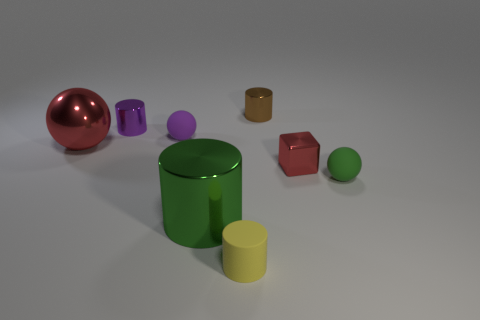What size is the purple object that is the same shape as the tiny green object?
Your answer should be compact. Small. There is a sphere that is behind the large red ball; does it have the same size as the sphere that is right of the tiny red cube?
Offer a terse response. Yes. What number of small objects are metallic things or red balls?
Your answer should be very brief. 3. How many small rubber things are to the left of the rubber cylinder and right of the red cube?
Provide a short and direct response. 0. Are the brown object and the red object on the left side of the tiny brown object made of the same material?
Offer a terse response. Yes. What number of cyan things are either small rubber cylinders or small blocks?
Your answer should be compact. 0. Is there a shiny thing that has the same size as the red metal ball?
Provide a succinct answer. Yes. What material is the red object right of the cylinder that is on the left side of the tiny matte object that is behind the tiny red metallic object made of?
Offer a very short reply. Metal. Are there the same number of big red shiny objects to the right of the small purple sphere and small yellow cylinders?
Provide a succinct answer. No. Are the green ball that is on the right side of the red block and the purple thing right of the tiny purple cylinder made of the same material?
Your answer should be very brief. Yes. 